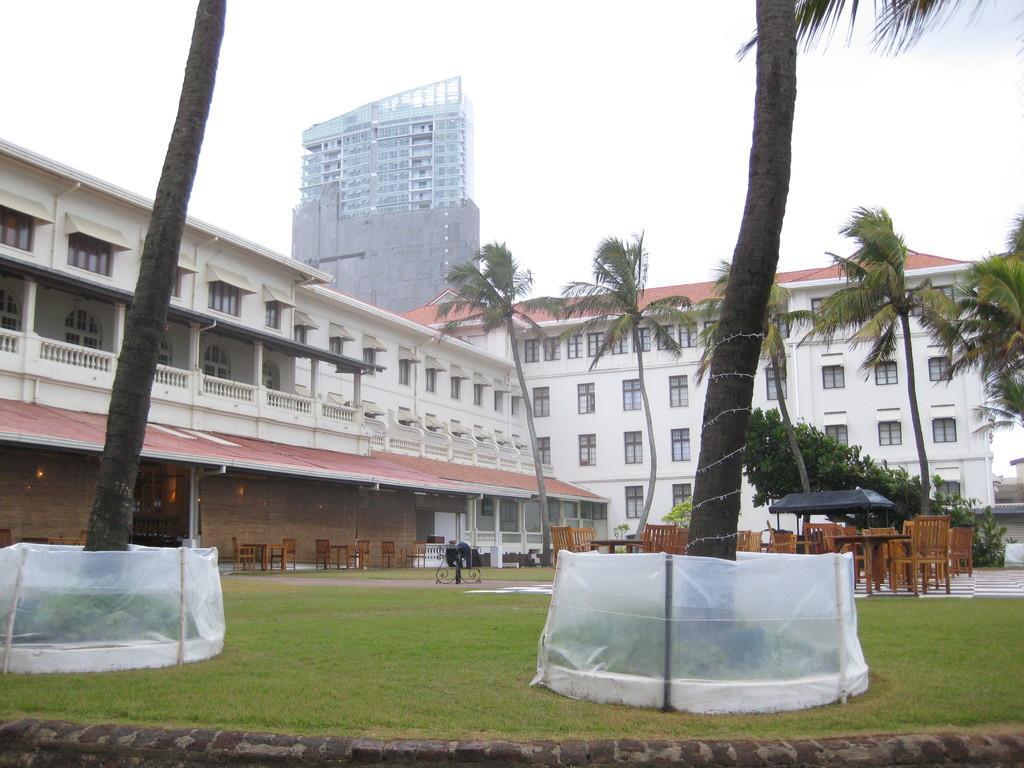Describe this image in one or two sentences. In this picture I can see tables, chairs, lights. There are buildings, trees, and in the background there is the sky. 